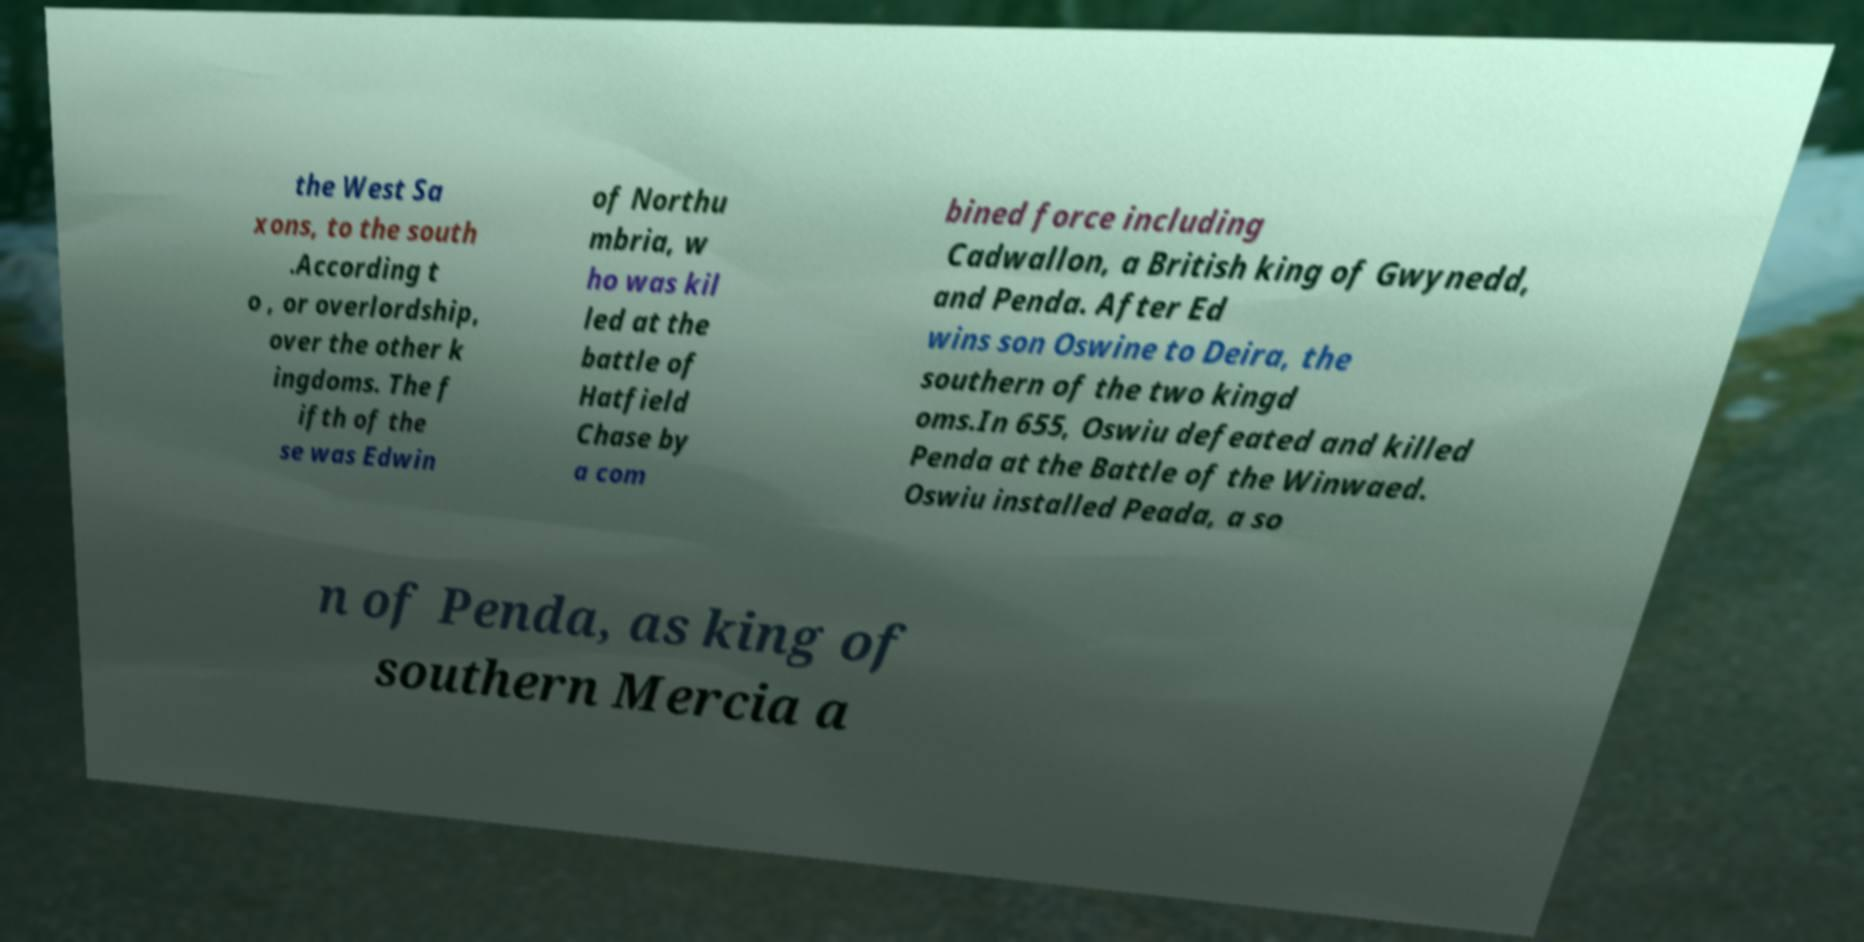Could you assist in decoding the text presented in this image and type it out clearly? the West Sa xons, to the south .According t o , or overlordship, over the other k ingdoms. The f ifth of the se was Edwin of Northu mbria, w ho was kil led at the battle of Hatfield Chase by a com bined force including Cadwallon, a British king of Gwynedd, and Penda. After Ed wins son Oswine to Deira, the southern of the two kingd oms.In 655, Oswiu defeated and killed Penda at the Battle of the Winwaed. Oswiu installed Peada, a so n of Penda, as king of southern Mercia a 